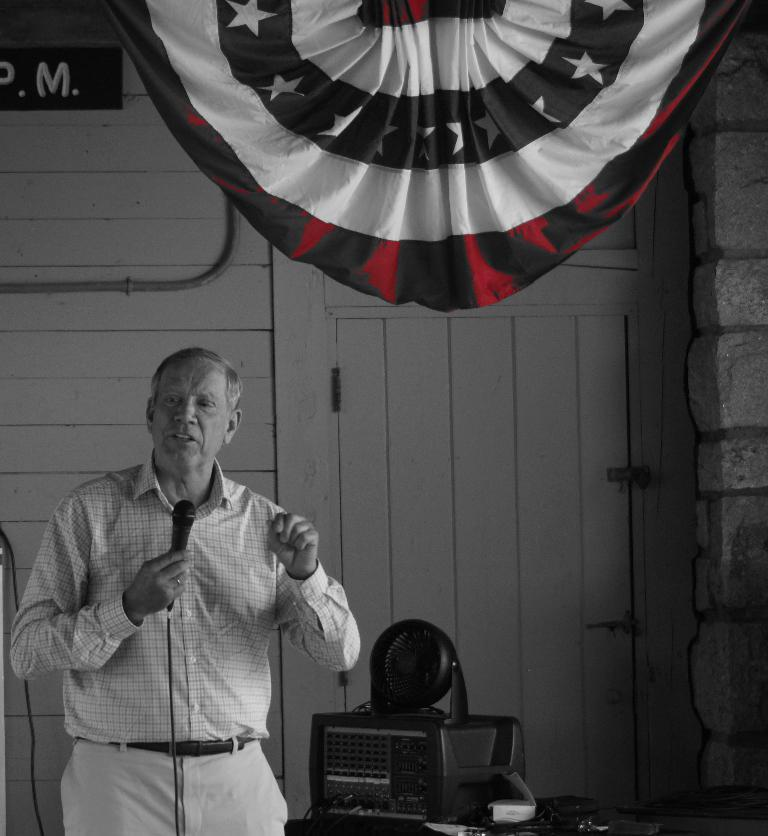What is the person in the image doing? The person is standing in the image and holding a mic. What object can be seen in the person's hand? The person is holding a mic. What type of electronic device is present in the image? There is an electronic gadget in the image. What can be seen in the background of the image? There is a curtain and a wooden wall in the background of the image. What type of produce is being displayed on the person's wing in the image? There is no wing or produce present in the image. 